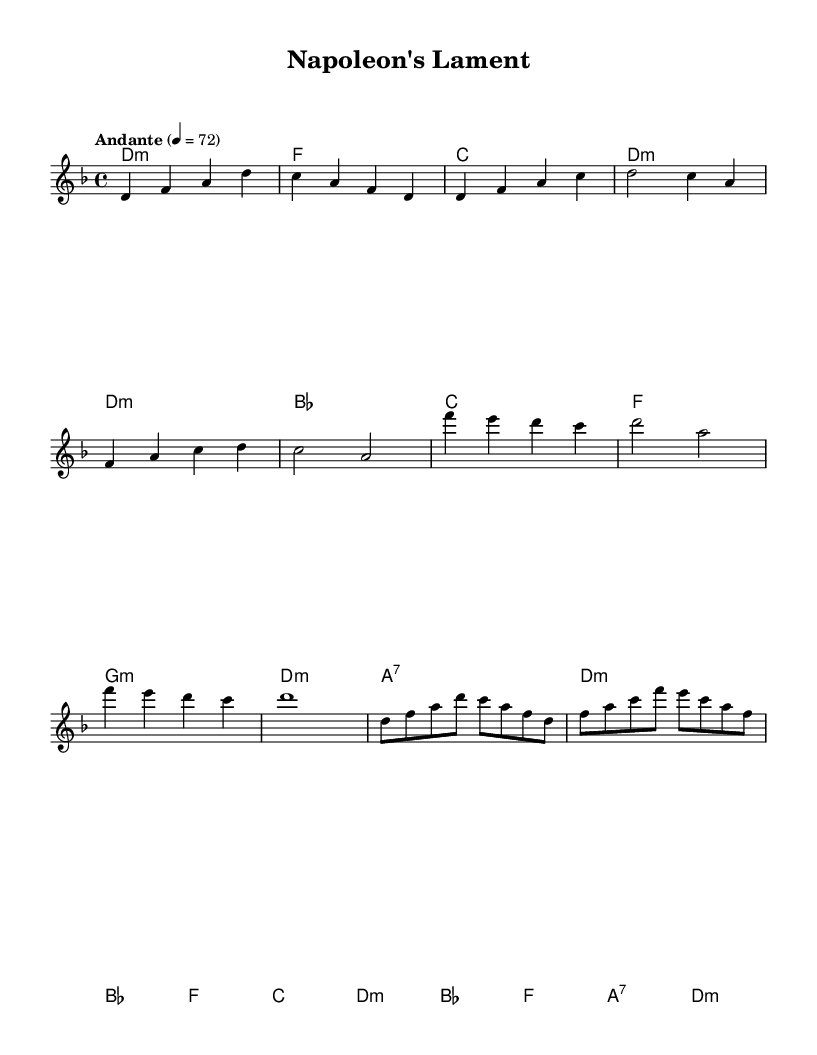What is the key signature of this music? The key signature is D minor, which has one flat (B flat). This can be determined from the global directives where the key is explicitly stated.
Answer: D minor What is the time signature of this music? The time signature is 4/4, indicated in the global directives as well. This means there are four beats in each measure.
Answer: 4/4 What is the tempo marking for this piece? The tempo marking is "Andante," which suggests a moderately slow pace. This is directly noted in the global directives as well.
Answer: Andante What is the first chord in the piece? The first chord in the intro is D minor, as denoted by "d1:m" in the harmonies section. This shows the harmonic foundation upon which the melody is built.
Answer: D minor How many measures are in the chorus section? There are four measures in the chorus section, confirmed by counting the measures in the written melody and harmonies. Each line in the melody corresponds to a separate measure.
Answer: 4 How does the melody approach the key change in the chorus? The melody transitions to a higher octave (starting with F') during the chorus, which emphasizes the emotional intensity typical in metal ballads. This upward melodic shift is common in the genre to enhance expressiveness.
Answer: F What type of musical development is present in this ballad compared to typical Metal songs? This ballad exhibits a more lyrical and emotional style, featuring long sustained notes, which contrasts with the fast-paced, aggressive sound commonly found in heavy metal. This deliberate pace and melodic focus signal its balladic nature.
Answer: Lyrical 